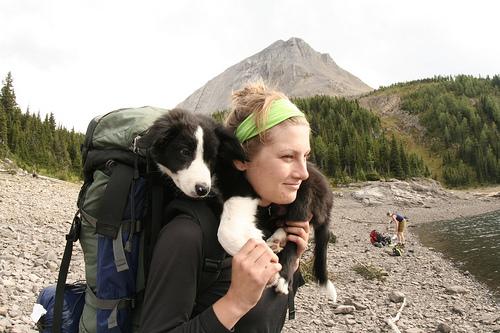Is she carrying the dog?
Quick response, please. Yes. What is behind the neck?
Short answer required. Dog. What could she be doing?
Answer briefly. Hiking. What color is the person's shirt?
Keep it brief. Black. 